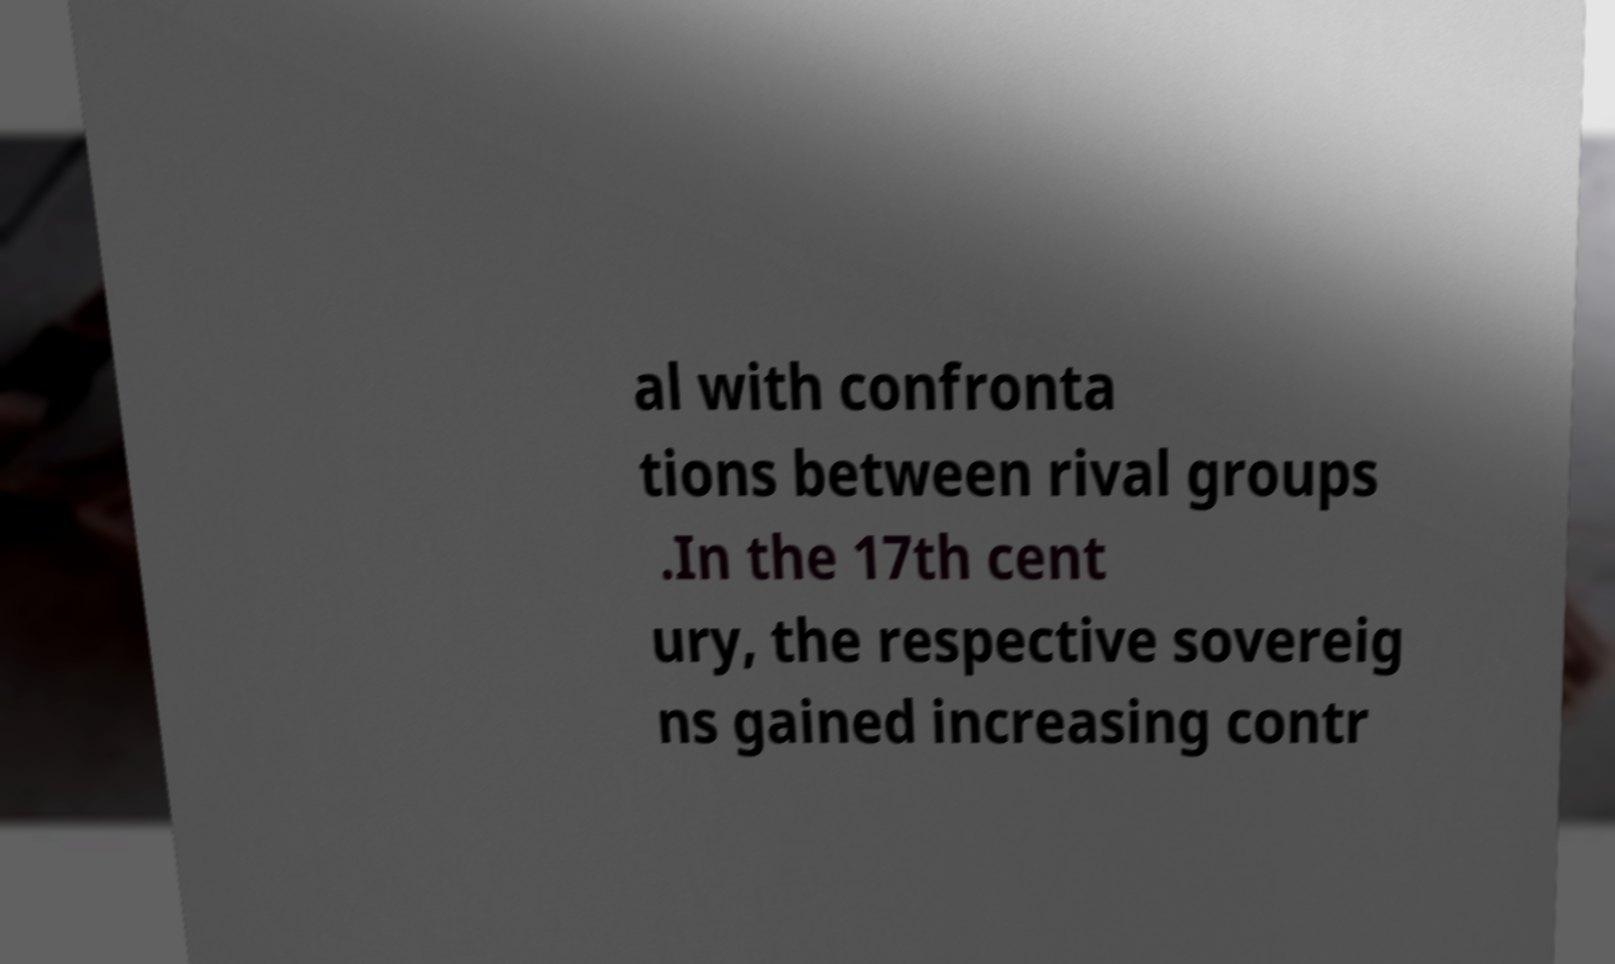For documentation purposes, I need the text within this image transcribed. Could you provide that? al with confronta tions between rival groups .In the 17th cent ury, the respective sovereig ns gained increasing contr 